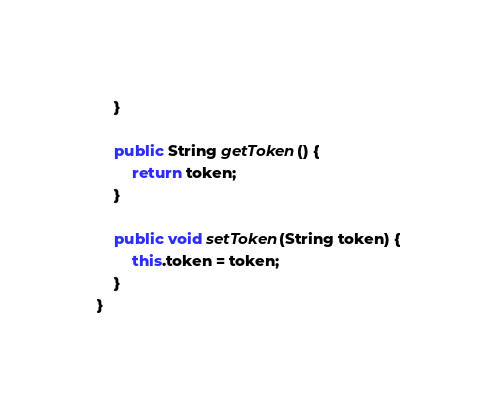Convert code to text. <code><loc_0><loc_0><loc_500><loc_500><_Java_>    }

    public String getToken() {
        return token;
    }

    public void setToken(String token) {
        this.token = token;
    }
}
</code> 